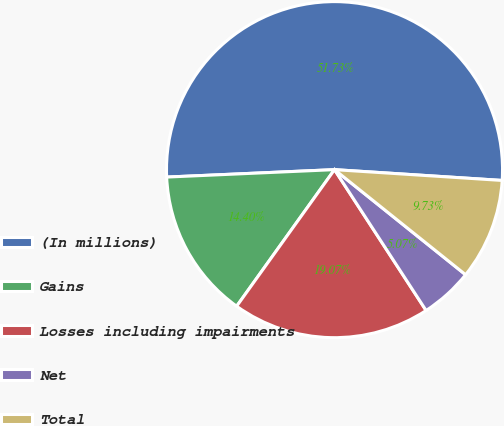Convert chart. <chart><loc_0><loc_0><loc_500><loc_500><pie_chart><fcel>(In millions)<fcel>Gains<fcel>Losses including impairments<fcel>Net<fcel>Total<nl><fcel>51.73%<fcel>14.4%<fcel>19.07%<fcel>5.07%<fcel>9.73%<nl></chart> 